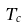<formula> <loc_0><loc_0><loc_500><loc_500>T _ { c }</formula> 